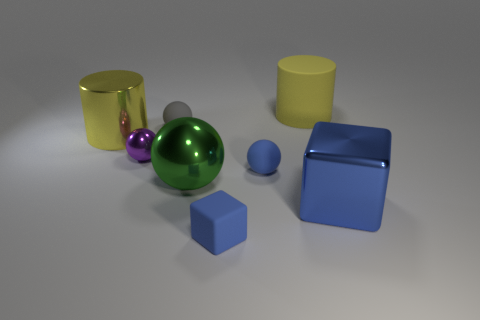How many big objects are either red metallic balls or matte spheres?
Ensure brevity in your answer.  0. Are there any other things of the same color as the big cube?
Keep it short and to the point. Yes. There is a tiny gray thing; are there any big metal things behind it?
Make the answer very short. No. There is a cube right of the tiny rubber thing on the right side of the blue matte block; what is its size?
Ensure brevity in your answer.  Large. Are there the same number of yellow cylinders to the left of the purple ball and yellow rubber cylinders that are right of the large yellow metal thing?
Ensure brevity in your answer.  Yes. There is a yellow cylinder that is on the right side of the gray matte sphere; are there any tiny blue matte blocks in front of it?
Give a very brief answer. Yes. There is a large yellow rubber cylinder behind the block that is behind the tiny rubber cube; what number of things are in front of it?
Offer a very short reply. 7. Is the number of brown rubber things less than the number of purple shiny spheres?
Your response must be concise. Yes. Is the shape of the metal thing on the left side of the purple thing the same as the big yellow object that is on the right side of the large green object?
Your response must be concise. Yes. The small block has what color?
Your response must be concise. Blue. 